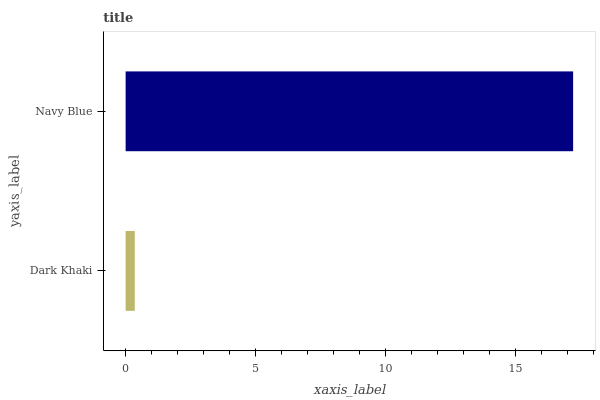Is Dark Khaki the minimum?
Answer yes or no. Yes. Is Navy Blue the maximum?
Answer yes or no. Yes. Is Navy Blue the minimum?
Answer yes or no. No. Is Navy Blue greater than Dark Khaki?
Answer yes or no. Yes. Is Dark Khaki less than Navy Blue?
Answer yes or no. Yes. Is Dark Khaki greater than Navy Blue?
Answer yes or no. No. Is Navy Blue less than Dark Khaki?
Answer yes or no. No. Is Navy Blue the high median?
Answer yes or no. Yes. Is Dark Khaki the low median?
Answer yes or no. Yes. Is Dark Khaki the high median?
Answer yes or no. No. Is Navy Blue the low median?
Answer yes or no. No. 